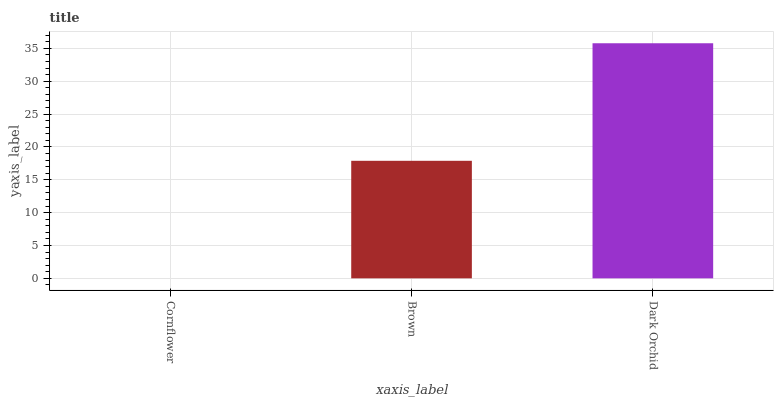Is Cornflower the minimum?
Answer yes or no. Yes. Is Dark Orchid the maximum?
Answer yes or no. Yes. Is Brown the minimum?
Answer yes or no. No. Is Brown the maximum?
Answer yes or no. No. Is Brown greater than Cornflower?
Answer yes or no. Yes. Is Cornflower less than Brown?
Answer yes or no. Yes. Is Cornflower greater than Brown?
Answer yes or no. No. Is Brown less than Cornflower?
Answer yes or no. No. Is Brown the high median?
Answer yes or no. Yes. Is Brown the low median?
Answer yes or no. Yes. Is Cornflower the high median?
Answer yes or no. No. Is Dark Orchid the low median?
Answer yes or no. No. 